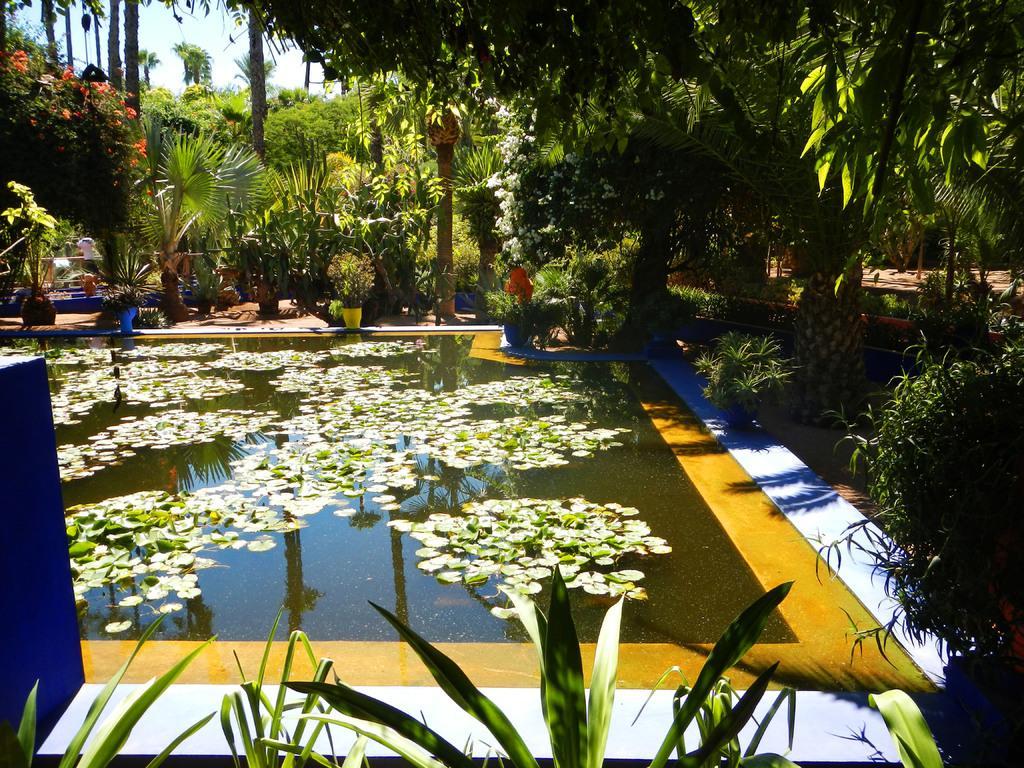Please provide a concise description of this image. This picture is clicked outside. In the foreground we can see the green leaves and the plants. In the center there is a water body containing the flowers and some objects and we can see the flowers, potted plants, trees and many other objects. In the background we can see the sky. 